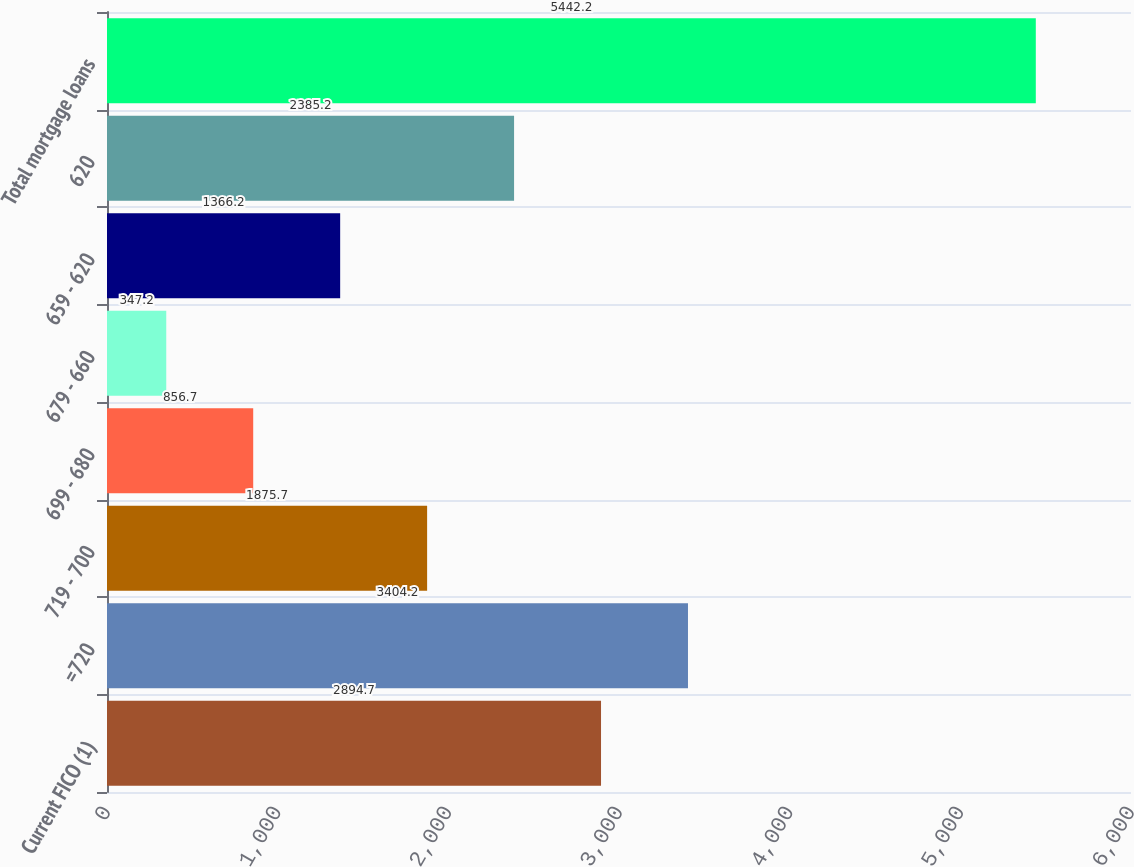<chart> <loc_0><loc_0><loc_500><loc_500><bar_chart><fcel>Current FICO (1)<fcel>=720<fcel>719 - 700<fcel>699 - 680<fcel>679 - 660<fcel>659 - 620<fcel>620<fcel>Total mortgage loans<nl><fcel>2894.7<fcel>3404.2<fcel>1875.7<fcel>856.7<fcel>347.2<fcel>1366.2<fcel>2385.2<fcel>5442.2<nl></chart> 